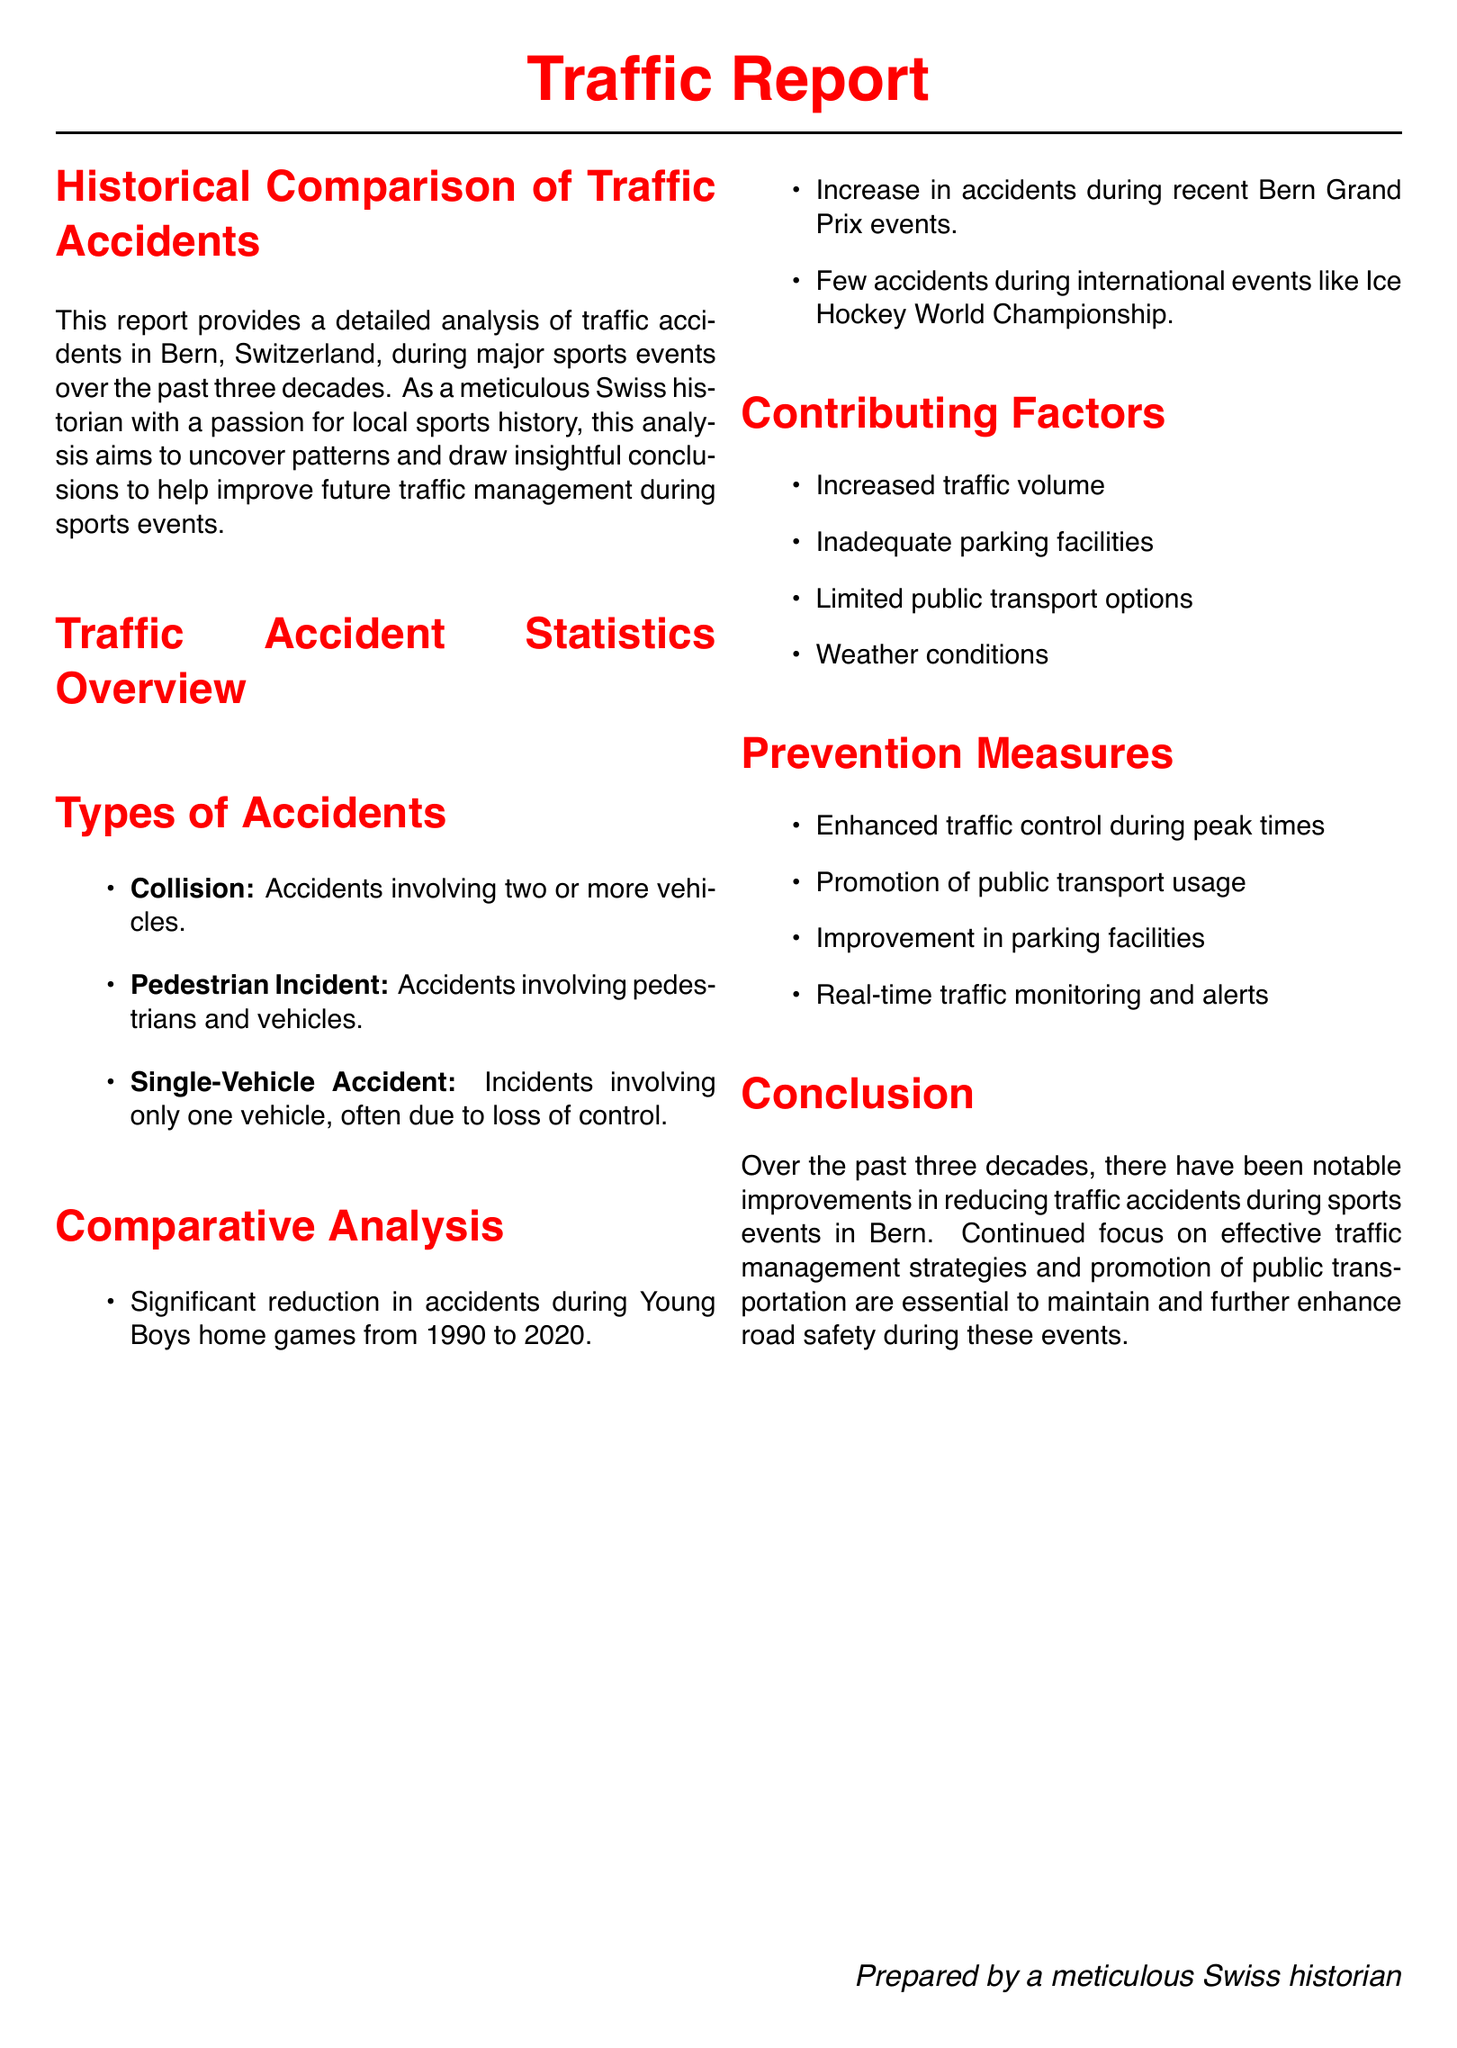what year had the highest number of accidents during a sports event? The year with the highest number of accidents during a sports event was 1990, with 12 accidents during a Young Boys home game.
Answer: 1990 how many accidents occurred during the Ice Hockey World Championship in 2013? There were 5 accidents during the Ice Hockey World Championship in 2013.
Answer: 5 what was the number of accidents reported during Young Boys home games from 1990 to 2020? The number of accidents reported during Young Boys home games from 1990 to 2020 was 12 in 1990 and 4 in 2020, showing a significant reduction.
Answer: 12 in 1990 and 4 in 2020 what contributing factor is mentioned that relates to parking? Inadequate parking facilities are mentioned as a contributing factor to traffic accidents during sports events.
Answer: Inadequate parking facilities which event in 2004 had the fewest reported accidents? The Bern Grand Prix in 2004 had the fewest reported accidents, totaling 7.
Answer: 7 what type of accident involves pedestrians? Accidents involving pedestrians and vehicles are classified as pedestrian incidents.
Answer: Pedestrian Incident which event saw an increase in accidents from previous events? The recent Bern Grand Prix events saw an increase in accidents compared to earlier years.
Answer: Bern Grand Prix what prevention measure aims to promote public transport usage? Promotion of public transport usage is listed as a prevention measure to help reduce traffic accidents.
Answer: Promotion of public transport usage how many accidents occurred during the 2018 Bern Grand Prix? There were 9 accidents during the 2018 Bern Grand Prix.
Answer: 9 